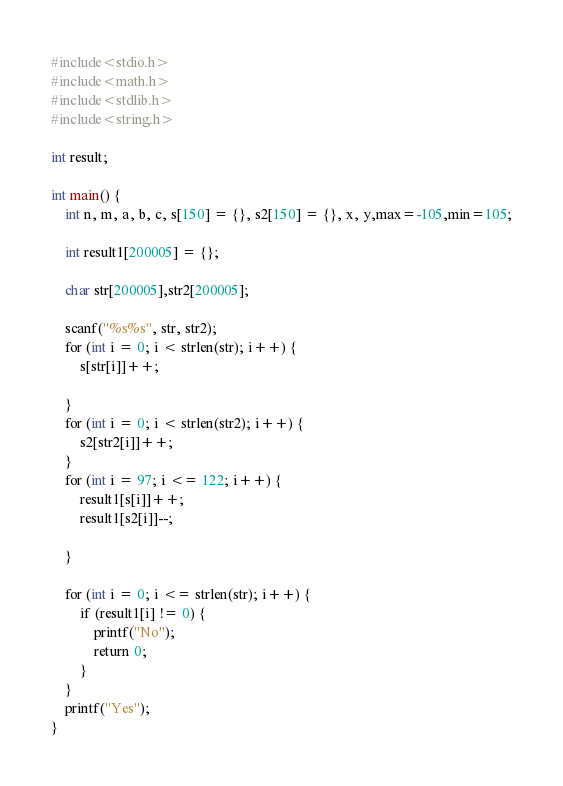<code> <loc_0><loc_0><loc_500><loc_500><_C_>#include<stdio.h>
#include<math.h>
#include<stdlib.h>
#include<string.h>

int result;

int main() {
	int n, m, a, b, c, s[150] = {}, s2[150] = {}, x, y,max=-105,min=105;

	int result1[200005] = {};

	char str[200005],str2[200005];

	scanf("%s%s", str, str2);
	for (int i = 0; i < strlen(str); i++) {
		s[str[i]]++;
		
	}
	for (int i = 0; i < strlen(str2); i++) {
		s2[str2[i]]++;
	}
	for (int i = 97; i <= 122; i++) {
		result1[s[i]]++;
		result1[s2[i]]--;
		
	}

	for (int i = 0; i <= strlen(str); i++) {
		if (result1[i] != 0) {
			printf("No");
			return 0;
		}
	}
	printf("Yes");
}</code> 